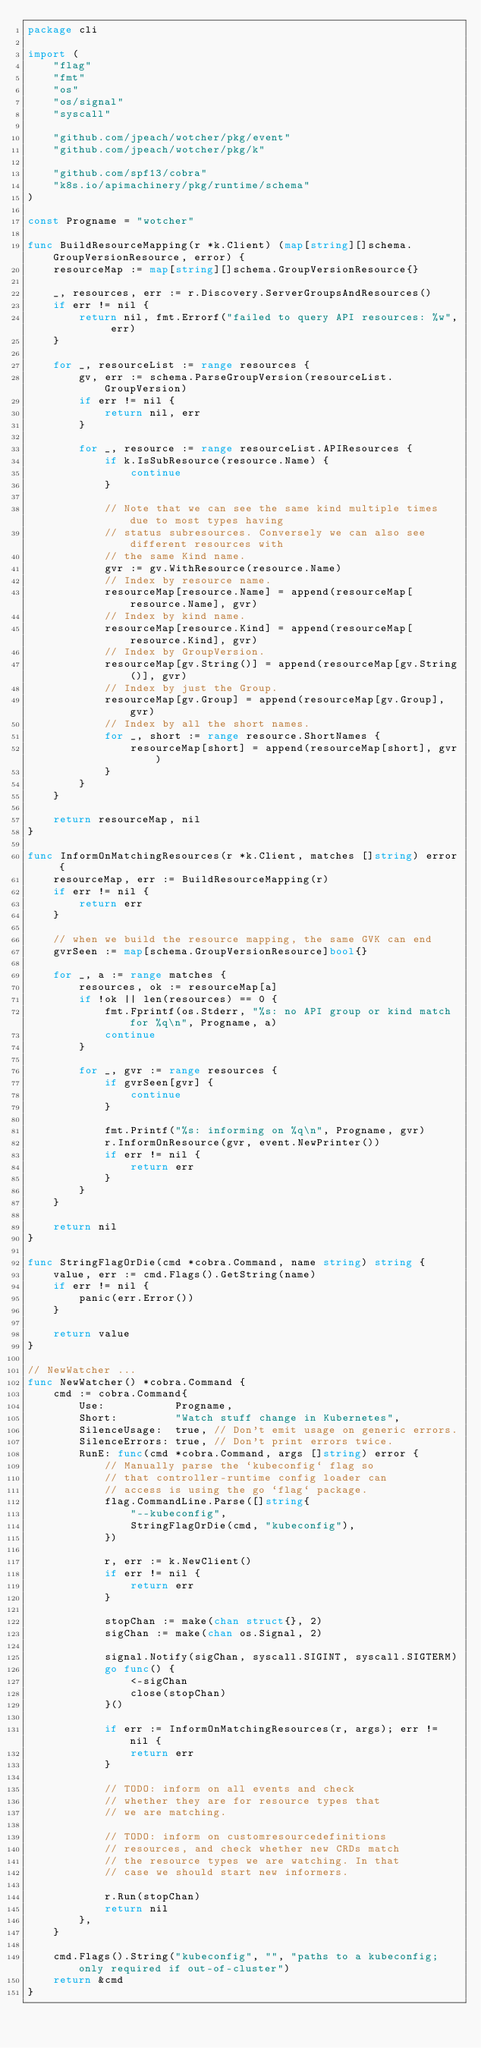Convert code to text. <code><loc_0><loc_0><loc_500><loc_500><_Go_>package cli

import (
	"flag"
	"fmt"
	"os"
	"os/signal"
	"syscall"

	"github.com/jpeach/wotcher/pkg/event"
	"github.com/jpeach/wotcher/pkg/k"

	"github.com/spf13/cobra"
	"k8s.io/apimachinery/pkg/runtime/schema"
)

const Progname = "wotcher"

func BuildResourceMapping(r *k.Client) (map[string][]schema.GroupVersionResource, error) {
	resourceMap := map[string][]schema.GroupVersionResource{}

	_, resources, err := r.Discovery.ServerGroupsAndResources()
	if err != nil {
		return nil, fmt.Errorf("failed to query API resources: %w", err)
	}

	for _, resourceList := range resources {
		gv, err := schema.ParseGroupVersion(resourceList.GroupVersion)
		if err != nil {
			return nil, err
		}

		for _, resource := range resourceList.APIResources {
			if k.IsSubResource(resource.Name) {
				continue
			}

			// Note that we can see the same kind multiple times due to most types having
			// status subresources. Conversely we can also see different resources with
			// the same Kind name.
			gvr := gv.WithResource(resource.Name)
			// Index by resource name.
			resourceMap[resource.Name] = append(resourceMap[resource.Name], gvr)
			// Index by kind name.
			resourceMap[resource.Kind] = append(resourceMap[resource.Kind], gvr)
			// Index by GroupVersion.
			resourceMap[gv.String()] = append(resourceMap[gv.String()], gvr)
			// Index by just the Group.
			resourceMap[gv.Group] = append(resourceMap[gv.Group], gvr)
			// Index by all the short names.
			for _, short := range resource.ShortNames {
				resourceMap[short] = append(resourceMap[short], gvr)
			}
		}
	}

	return resourceMap, nil
}

func InformOnMatchingResources(r *k.Client, matches []string) error {
	resourceMap, err := BuildResourceMapping(r)
	if err != nil {
		return err
	}

	// when we build the resource mapping, the same GVK can end
	gvrSeen := map[schema.GroupVersionResource]bool{}

	for _, a := range matches {
		resources, ok := resourceMap[a]
		if !ok || len(resources) == 0 {
			fmt.Fprintf(os.Stderr, "%s: no API group or kind match for %q\n", Progname, a)
			continue
		}

		for _, gvr := range resources {
			if gvrSeen[gvr] {
				continue
			}

			fmt.Printf("%s: informing on %q\n", Progname, gvr)
			r.InformOnResource(gvr, event.NewPrinter())
			if err != nil {
				return err
			}
		}
	}

	return nil
}

func StringFlagOrDie(cmd *cobra.Command, name string) string {
	value, err := cmd.Flags().GetString(name)
	if err != nil {
		panic(err.Error())
	}

	return value
}

// NewWatcher ...
func NewWatcher() *cobra.Command {
	cmd := cobra.Command{
		Use:           Progname,
		Short:         "Watch stuff change in Kubernetes",
		SilenceUsage:  true, // Don't emit usage on generic errors.
		SilenceErrors: true, // Don't print errors twice.
		RunE: func(cmd *cobra.Command, args []string) error {
			// Manually parse the `kubeconfig` flag so
			// that controller-runtime config loader can
			// access is using the go `flag` package.
			flag.CommandLine.Parse([]string{
				"--kubeconfig",
				StringFlagOrDie(cmd, "kubeconfig"),
			})

			r, err := k.NewClient()
			if err != nil {
				return err
			}

			stopChan := make(chan struct{}, 2)
			sigChan := make(chan os.Signal, 2)

			signal.Notify(sigChan, syscall.SIGINT, syscall.SIGTERM)
			go func() {
				<-sigChan
				close(stopChan)
			}()

			if err := InformOnMatchingResources(r, args); err != nil {
				return err
			}

			// TODO: inform on all events and check
			// whether they are for resource types that
			// we are matching.

			// TODO: inform on customresourcedefinitions
			// resources, and check whether new CRDs match
			// the resource types we are watching. In that
			// case we should start new informers.

			r.Run(stopChan)
			return nil
		},
	}

	cmd.Flags().String("kubeconfig", "", "paths to a kubeconfig; only required if out-of-cluster")
	return &cmd
}
</code> 